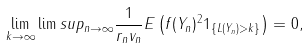Convert formula to latex. <formula><loc_0><loc_0><loc_500><loc_500>\lim _ { k \to \infty } \lim s u p _ { n \to \infty } \frac { 1 } { r _ { n } v _ { n } } E \left ( f ( Y _ { n } ) ^ { 2 } 1 _ { \{ L ( Y _ { n } ) > k \} } \right ) = 0 ,</formula> 